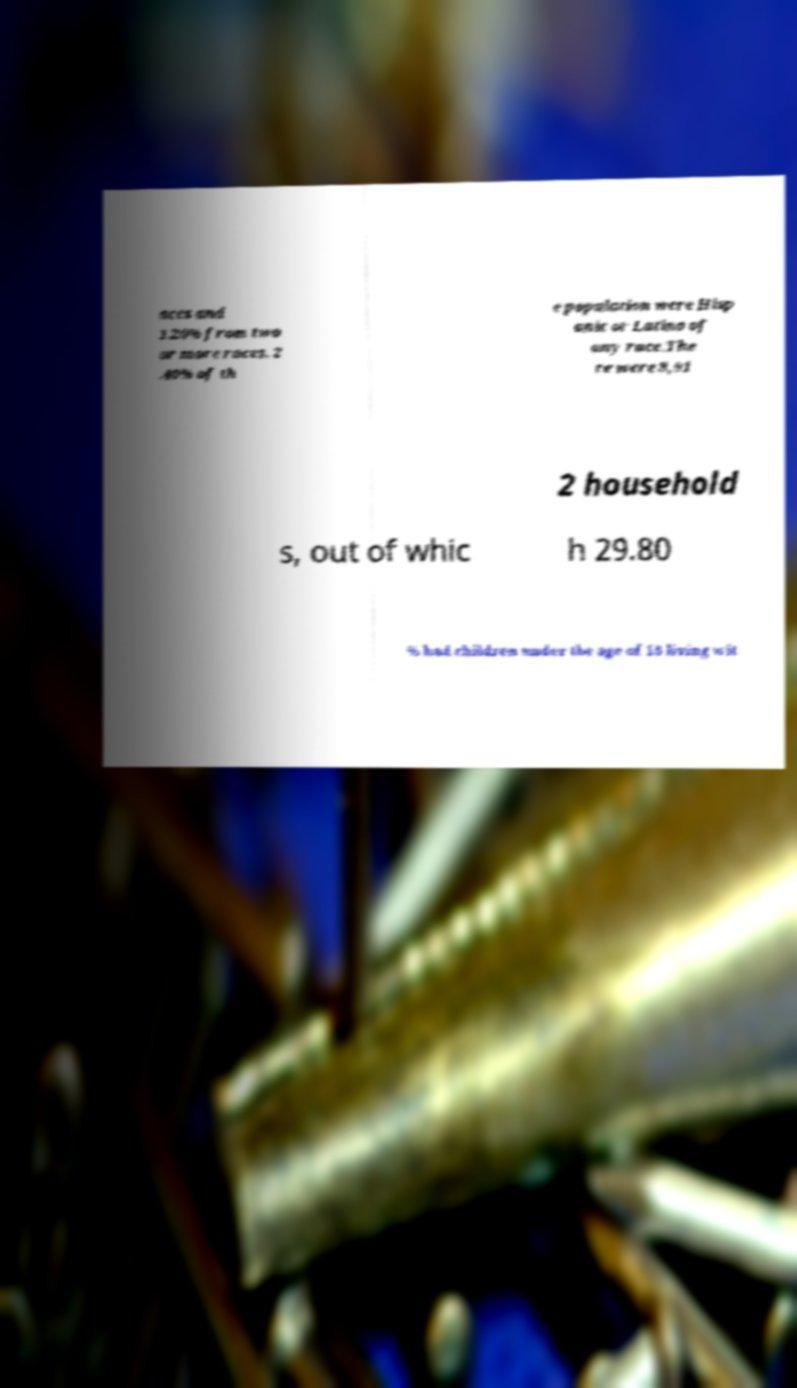Please read and relay the text visible in this image. What does it say? aces and 1.20% from two or more races. 2 .40% of th e population were Hisp anic or Latino of any race.The re were 8,91 2 household s, out of whic h 29.80 % had children under the age of 18 living wit 